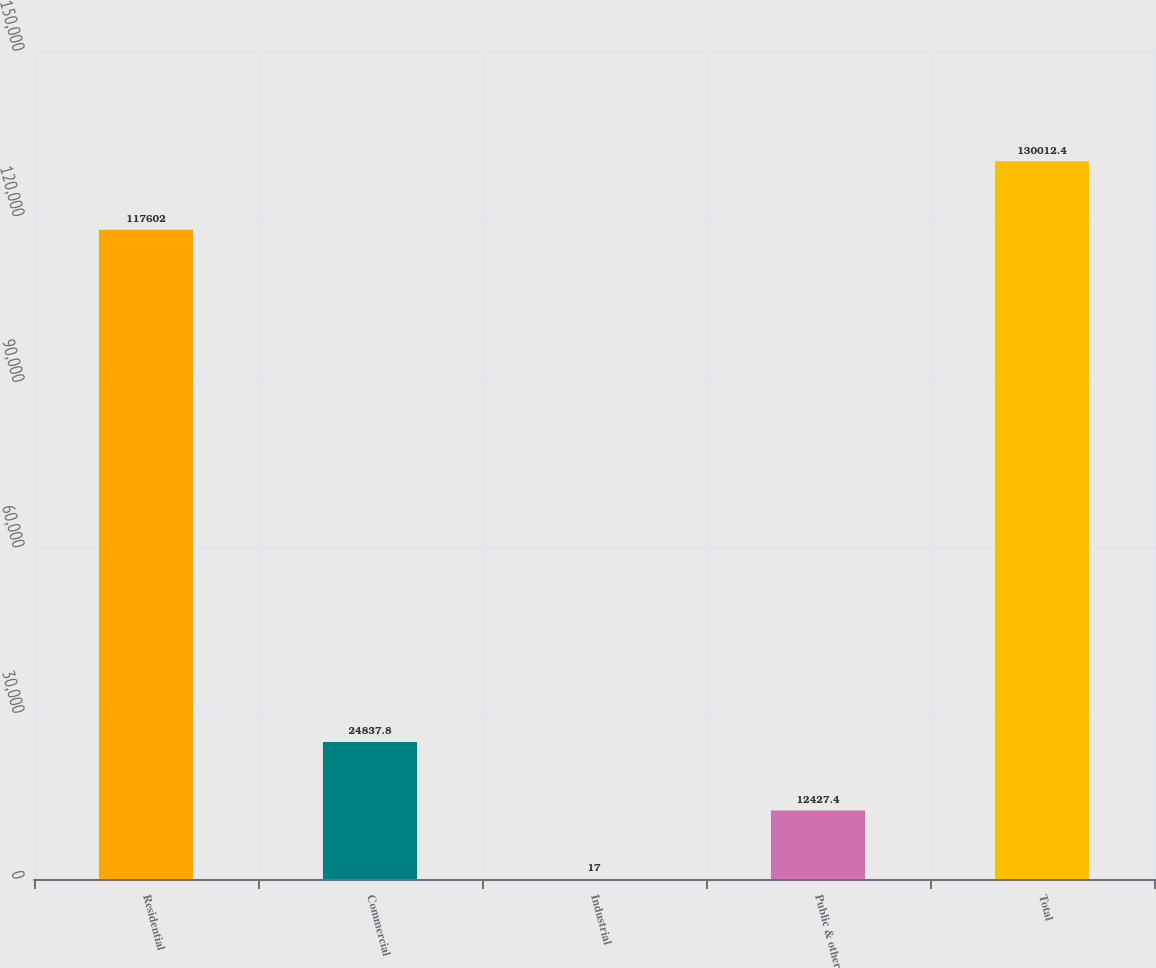Convert chart. <chart><loc_0><loc_0><loc_500><loc_500><bar_chart><fcel>Residential<fcel>Commercial<fcel>Industrial<fcel>Public & other<fcel>Total<nl><fcel>117602<fcel>24837.8<fcel>17<fcel>12427.4<fcel>130012<nl></chart> 